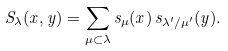Convert formula to latex. <formula><loc_0><loc_0><loc_500><loc_500>S _ { \lambda } ( x , y ) = \sum _ { \mu \subset \lambda } s _ { \mu } ( x ) \, s _ { \lambda ^ { \prime } / \mu ^ { \prime } } ( y ) .</formula> 